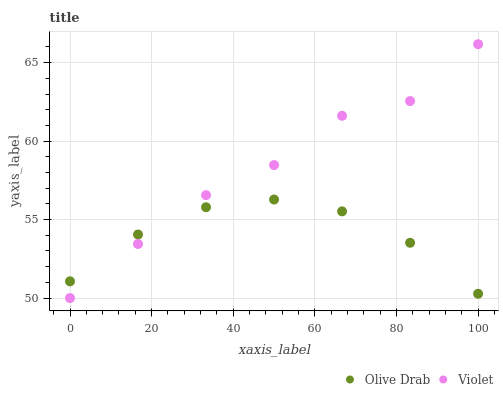Does Olive Drab have the minimum area under the curve?
Answer yes or no. Yes. Does Violet have the maximum area under the curve?
Answer yes or no. Yes. Does Violet have the minimum area under the curve?
Answer yes or no. No. Is Olive Drab the smoothest?
Answer yes or no. Yes. Is Violet the roughest?
Answer yes or no. Yes. Is Violet the smoothest?
Answer yes or no. No. Does Violet have the lowest value?
Answer yes or no. Yes. Does Violet have the highest value?
Answer yes or no. Yes. Does Olive Drab intersect Violet?
Answer yes or no. Yes. Is Olive Drab less than Violet?
Answer yes or no. No. Is Olive Drab greater than Violet?
Answer yes or no. No. 